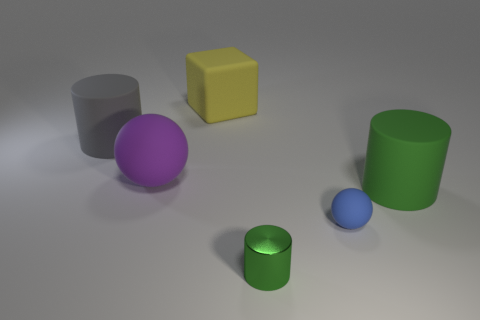What number of other objects are the same material as the blue sphere?
Your answer should be very brief. 4. What number of things are either balls that are on the left side of the small green metal object or blue rubber balls?
Offer a terse response. 2. The large object in front of the sphere that is on the left side of the tiny metal cylinder is what shape?
Your answer should be very brief. Cylinder. Is the shape of the big thing right of the large matte block the same as  the small metallic object?
Give a very brief answer. Yes. What color is the matte sphere that is in front of the purple matte thing?
Make the answer very short. Blue. What number of spheres are either purple rubber objects or large red things?
Your answer should be very brief. 1. There is a green thing that is behind the matte thing that is in front of the big green matte cylinder; how big is it?
Make the answer very short. Large. Is the color of the small cylinder the same as the large thing that is right of the metallic thing?
Keep it short and to the point. Yes. What number of objects are behind the green matte cylinder?
Offer a very short reply. 3. Are there fewer tiny balls than yellow rubber cylinders?
Your response must be concise. No. 